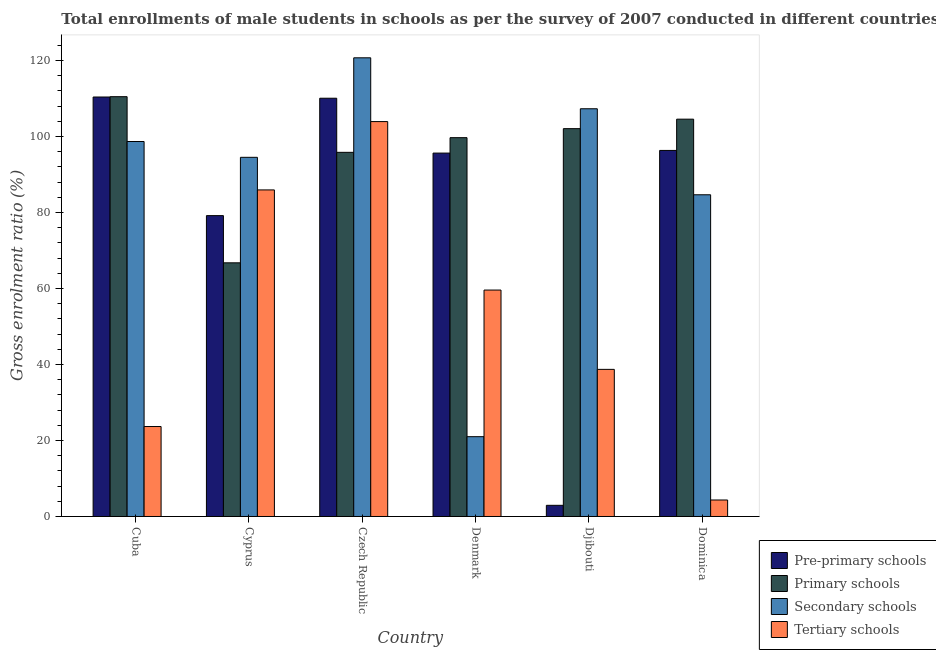How many different coloured bars are there?
Offer a very short reply. 4. Are the number of bars on each tick of the X-axis equal?
Give a very brief answer. Yes. How many bars are there on the 2nd tick from the left?
Your response must be concise. 4. How many bars are there on the 4th tick from the right?
Provide a succinct answer. 4. What is the label of the 3rd group of bars from the left?
Offer a terse response. Czech Republic. In how many cases, is the number of bars for a given country not equal to the number of legend labels?
Your response must be concise. 0. What is the gross enrolment ratio(male) in pre-primary schools in Denmark?
Offer a terse response. 95.65. Across all countries, what is the maximum gross enrolment ratio(male) in pre-primary schools?
Your answer should be very brief. 110.41. Across all countries, what is the minimum gross enrolment ratio(male) in secondary schools?
Provide a succinct answer. 21.01. In which country was the gross enrolment ratio(male) in pre-primary schools maximum?
Make the answer very short. Cuba. In which country was the gross enrolment ratio(male) in primary schools minimum?
Give a very brief answer. Cyprus. What is the total gross enrolment ratio(male) in tertiary schools in the graph?
Offer a very short reply. 316.23. What is the difference between the gross enrolment ratio(male) in secondary schools in Cyprus and that in Czech Republic?
Your response must be concise. -26.19. What is the difference between the gross enrolment ratio(male) in pre-primary schools in Denmark and the gross enrolment ratio(male) in secondary schools in Czech Republic?
Offer a terse response. -25.08. What is the average gross enrolment ratio(male) in pre-primary schools per country?
Your answer should be very brief. 82.44. What is the difference between the gross enrolment ratio(male) in tertiary schools and gross enrolment ratio(male) in primary schools in Dominica?
Keep it short and to the point. -100.24. In how many countries, is the gross enrolment ratio(male) in secondary schools greater than 20 %?
Your response must be concise. 6. What is the ratio of the gross enrolment ratio(male) in secondary schools in Cyprus to that in Denmark?
Make the answer very short. 4.5. What is the difference between the highest and the second highest gross enrolment ratio(male) in secondary schools?
Your answer should be compact. 13.41. What is the difference between the highest and the lowest gross enrolment ratio(male) in primary schools?
Offer a terse response. 43.73. What does the 1st bar from the left in Denmark represents?
Ensure brevity in your answer.  Pre-primary schools. What does the 3rd bar from the right in Cyprus represents?
Provide a succinct answer. Primary schools. How many countries are there in the graph?
Provide a short and direct response. 6. What is the difference between two consecutive major ticks on the Y-axis?
Provide a succinct answer. 20. Are the values on the major ticks of Y-axis written in scientific E-notation?
Give a very brief answer. No. Does the graph contain grids?
Give a very brief answer. No. Where does the legend appear in the graph?
Your response must be concise. Bottom right. How many legend labels are there?
Offer a terse response. 4. How are the legend labels stacked?
Offer a very short reply. Vertical. What is the title of the graph?
Provide a short and direct response. Total enrollments of male students in schools as per the survey of 2007 conducted in different countries. What is the label or title of the Y-axis?
Offer a terse response. Gross enrolment ratio (%). What is the Gross enrolment ratio (%) in Pre-primary schools in Cuba?
Provide a succinct answer. 110.41. What is the Gross enrolment ratio (%) of Primary schools in Cuba?
Ensure brevity in your answer.  110.49. What is the Gross enrolment ratio (%) in Secondary schools in Cuba?
Ensure brevity in your answer.  98.69. What is the Gross enrolment ratio (%) in Tertiary schools in Cuba?
Ensure brevity in your answer.  23.68. What is the Gross enrolment ratio (%) of Pre-primary schools in Cyprus?
Make the answer very short. 79.19. What is the Gross enrolment ratio (%) in Primary schools in Cyprus?
Give a very brief answer. 66.77. What is the Gross enrolment ratio (%) in Secondary schools in Cyprus?
Provide a short and direct response. 94.53. What is the Gross enrolment ratio (%) of Tertiary schools in Cyprus?
Ensure brevity in your answer.  85.95. What is the Gross enrolment ratio (%) in Pre-primary schools in Czech Republic?
Your answer should be very brief. 110.09. What is the Gross enrolment ratio (%) in Primary schools in Czech Republic?
Offer a very short reply. 95.84. What is the Gross enrolment ratio (%) in Secondary schools in Czech Republic?
Provide a succinct answer. 120.72. What is the Gross enrolment ratio (%) of Tertiary schools in Czech Republic?
Provide a succinct answer. 103.94. What is the Gross enrolment ratio (%) in Pre-primary schools in Denmark?
Offer a very short reply. 95.65. What is the Gross enrolment ratio (%) of Primary schools in Denmark?
Offer a terse response. 99.71. What is the Gross enrolment ratio (%) of Secondary schools in Denmark?
Your answer should be very brief. 21.01. What is the Gross enrolment ratio (%) of Tertiary schools in Denmark?
Provide a succinct answer. 59.6. What is the Gross enrolment ratio (%) of Pre-primary schools in Djibouti?
Make the answer very short. 2.94. What is the Gross enrolment ratio (%) in Primary schools in Djibouti?
Ensure brevity in your answer.  102.08. What is the Gross enrolment ratio (%) in Secondary schools in Djibouti?
Your answer should be compact. 107.32. What is the Gross enrolment ratio (%) of Tertiary schools in Djibouti?
Make the answer very short. 38.72. What is the Gross enrolment ratio (%) of Pre-primary schools in Dominica?
Ensure brevity in your answer.  96.35. What is the Gross enrolment ratio (%) of Primary schools in Dominica?
Make the answer very short. 104.58. What is the Gross enrolment ratio (%) of Secondary schools in Dominica?
Provide a short and direct response. 84.67. What is the Gross enrolment ratio (%) of Tertiary schools in Dominica?
Keep it short and to the point. 4.34. Across all countries, what is the maximum Gross enrolment ratio (%) of Pre-primary schools?
Give a very brief answer. 110.41. Across all countries, what is the maximum Gross enrolment ratio (%) in Primary schools?
Provide a short and direct response. 110.49. Across all countries, what is the maximum Gross enrolment ratio (%) in Secondary schools?
Offer a very short reply. 120.72. Across all countries, what is the maximum Gross enrolment ratio (%) of Tertiary schools?
Provide a short and direct response. 103.94. Across all countries, what is the minimum Gross enrolment ratio (%) of Pre-primary schools?
Offer a terse response. 2.94. Across all countries, what is the minimum Gross enrolment ratio (%) of Primary schools?
Your answer should be very brief. 66.77. Across all countries, what is the minimum Gross enrolment ratio (%) in Secondary schools?
Give a very brief answer. 21.01. Across all countries, what is the minimum Gross enrolment ratio (%) in Tertiary schools?
Make the answer very short. 4.34. What is the total Gross enrolment ratio (%) in Pre-primary schools in the graph?
Provide a short and direct response. 494.61. What is the total Gross enrolment ratio (%) in Primary schools in the graph?
Your answer should be very brief. 579.47. What is the total Gross enrolment ratio (%) in Secondary schools in the graph?
Your response must be concise. 526.95. What is the total Gross enrolment ratio (%) of Tertiary schools in the graph?
Your response must be concise. 316.23. What is the difference between the Gross enrolment ratio (%) of Pre-primary schools in Cuba and that in Cyprus?
Your answer should be very brief. 31.22. What is the difference between the Gross enrolment ratio (%) of Primary schools in Cuba and that in Cyprus?
Your answer should be compact. 43.73. What is the difference between the Gross enrolment ratio (%) in Secondary schools in Cuba and that in Cyprus?
Your answer should be very brief. 4.16. What is the difference between the Gross enrolment ratio (%) in Tertiary schools in Cuba and that in Cyprus?
Provide a succinct answer. -62.27. What is the difference between the Gross enrolment ratio (%) in Pre-primary schools in Cuba and that in Czech Republic?
Keep it short and to the point. 0.32. What is the difference between the Gross enrolment ratio (%) in Primary schools in Cuba and that in Czech Republic?
Provide a short and direct response. 14.65. What is the difference between the Gross enrolment ratio (%) of Secondary schools in Cuba and that in Czech Republic?
Keep it short and to the point. -22.03. What is the difference between the Gross enrolment ratio (%) of Tertiary schools in Cuba and that in Czech Republic?
Ensure brevity in your answer.  -80.26. What is the difference between the Gross enrolment ratio (%) of Pre-primary schools in Cuba and that in Denmark?
Offer a terse response. 14.76. What is the difference between the Gross enrolment ratio (%) in Primary schools in Cuba and that in Denmark?
Provide a short and direct response. 10.78. What is the difference between the Gross enrolment ratio (%) of Secondary schools in Cuba and that in Denmark?
Offer a terse response. 77.69. What is the difference between the Gross enrolment ratio (%) in Tertiary schools in Cuba and that in Denmark?
Provide a succinct answer. -35.92. What is the difference between the Gross enrolment ratio (%) of Pre-primary schools in Cuba and that in Djibouti?
Ensure brevity in your answer.  107.47. What is the difference between the Gross enrolment ratio (%) in Primary schools in Cuba and that in Djibouti?
Make the answer very short. 8.41. What is the difference between the Gross enrolment ratio (%) in Secondary schools in Cuba and that in Djibouti?
Offer a very short reply. -8.62. What is the difference between the Gross enrolment ratio (%) of Tertiary schools in Cuba and that in Djibouti?
Ensure brevity in your answer.  -15.04. What is the difference between the Gross enrolment ratio (%) in Pre-primary schools in Cuba and that in Dominica?
Provide a short and direct response. 14.06. What is the difference between the Gross enrolment ratio (%) in Primary schools in Cuba and that in Dominica?
Offer a very short reply. 5.92. What is the difference between the Gross enrolment ratio (%) in Secondary schools in Cuba and that in Dominica?
Provide a short and direct response. 14.02. What is the difference between the Gross enrolment ratio (%) in Tertiary schools in Cuba and that in Dominica?
Keep it short and to the point. 19.34. What is the difference between the Gross enrolment ratio (%) in Pre-primary schools in Cyprus and that in Czech Republic?
Offer a terse response. -30.9. What is the difference between the Gross enrolment ratio (%) of Primary schools in Cyprus and that in Czech Republic?
Provide a short and direct response. -29.08. What is the difference between the Gross enrolment ratio (%) of Secondary schools in Cyprus and that in Czech Republic?
Ensure brevity in your answer.  -26.19. What is the difference between the Gross enrolment ratio (%) of Tertiary schools in Cyprus and that in Czech Republic?
Offer a terse response. -17.99. What is the difference between the Gross enrolment ratio (%) in Pre-primary schools in Cyprus and that in Denmark?
Give a very brief answer. -16.46. What is the difference between the Gross enrolment ratio (%) of Primary schools in Cyprus and that in Denmark?
Your answer should be compact. -32.94. What is the difference between the Gross enrolment ratio (%) of Secondary schools in Cyprus and that in Denmark?
Offer a terse response. 73.53. What is the difference between the Gross enrolment ratio (%) of Tertiary schools in Cyprus and that in Denmark?
Ensure brevity in your answer.  26.35. What is the difference between the Gross enrolment ratio (%) of Pre-primary schools in Cyprus and that in Djibouti?
Ensure brevity in your answer.  76.25. What is the difference between the Gross enrolment ratio (%) of Primary schools in Cyprus and that in Djibouti?
Give a very brief answer. -35.31. What is the difference between the Gross enrolment ratio (%) in Secondary schools in Cyprus and that in Djibouti?
Make the answer very short. -12.79. What is the difference between the Gross enrolment ratio (%) of Tertiary schools in Cyprus and that in Djibouti?
Provide a succinct answer. 47.23. What is the difference between the Gross enrolment ratio (%) of Pre-primary schools in Cyprus and that in Dominica?
Give a very brief answer. -17.16. What is the difference between the Gross enrolment ratio (%) of Primary schools in Cyprus and that in Dominica?
Give a very brief answer. -37.81. What is the difference between the Gross enrolment ratio (%) of Secondary schools in Cyprus and that in Dominica?
Your answer should be compact. 9.86. What is the difference between the Gross enrolment ratio (%) of Tertiary schools in Cyprus and that in Dominica?
Your answer should be compact. 81.61. What is the difference between the Gross enrolment ratio (%) of Pre-primary schools in Czech Republic and that in Denmark?
Your response must be concise. 14.44. What is the difference between the Gross enrolment ratio (%) in Primary schools in Czech Republic and that in Denmark?
Your response must be concise. -3.86. What is the difference between the Gross enrolment ratio (%) in Secondary schools in Czech Republic and that in Denmark?
Ensure brevity in your answer.  99.72. What is the difference between the Gross enrolment ratio (%) of Tertiary schools in Czech Republic and that in Denmark?
Your answer should be compact. 44.34. What is the difference between the Gross enrolment ratio (%) in Pre-primary schools in Czech Republic and that in Djibouti?
Provide a short and direct response. 107.15. What is the difference between the Gross enrolment ratio (%) in Primary schools in Czech Republic and that in Djibouti?
Your response must be concise. -6.23. What is the difference between the Gross enrolment ratio (%) of Secondary schools in Czech Republic and that in Djibouti?
Provide a short and direct response. 13.41. What is the difference between the Gross enrolment ratio (%) in Tertiary schools in Czech Republic and that in Djibouti?
Your response must be concise. 65.22. What is the difference between the Gross enrolment ratio (%) of Pre-primary schools in Czech Republic and that in Dominica?
Provide a short and direct response. 13.74. What is the difference between the Gross enrolment ratio (%) of Primary schools in Czech Republic and that in Dominica?
Your answer should be very brief. -8.73. What is the difference between the Gross enrolment ratio (%) of Secondary schools in Czech Republic and that in Dominica?
Offer a very short reply. 36.05. What is the difference between the Gross enrolment ratio (%) of Tertiary schools in Czech Republic and that in Dominica?
Provide a succinct answer. 99.6. What is the difference between the Gross enrolment ratio (%) in Pre-primary schools in Denmark and that in Djibouti?
Provide a succinct answer. 92.71. What is the difference between the Gross enrolment ratio (%) in Primary schools in Denmark and that in Djibouti?
Ensure brevity in your answer.  -2.37. What is the difference between the Gross enrolment ratio (%) in Secondary schools in Denmark and that in Djibouti?
Provide a succinct answer. -86.31. What is the difference between the Gross enrolment ratio (%) in Tertiary schools in Denmark and that in Djibouti?
Offer a very short reply. 20.88. What is the difference between the Gross enrolment ratio (%) in Pre-primary schools in Denmark and that in Dominica?
Make the answer very short. -0.7. What is the difference between the Gross enrolment ratio (%) of Primary schools in Denmark and that in Dominica?
Your answer should be very brief. -4.87. What is the difference between the Gross enrolment ratio (%) in Secondary schools in Denmark and that in Dominica?
Give a very brief answer. -63.67. What is the difference between the Gross enrolment ratio (%) in Tertiary schools in Denmark and that in Dominica?
Provide a short and direct response. 55.26. What is the difference between the Gross enrolment ratio (%) of Pre-primary schools in Djibouti and that in Dominica?
Offer a terse response. -93.41. What is the difference between the Gross enrolment ratio (%) in Primary schools in Djibouti and that in Dominica?
Offer a very short reply. -2.5. What is the difference between the Gross enrolment ratio (%) in Secondary schools in Djibouti and that in Dominica?
Make the answer very short. 22.64. What is the difference between the Gross enrolment ratio (%) of Tertiary schools in Djibouti and that in Dominica?
Give a very brief answer. 34.38. What is the difference between the Gross enrolment ratio (%) in Pre-primary schools in Cuba and the Gross enrolment ratio (%) in Primary schools in Cyprus?
Provide a short and direct response. 43.64. What is the difference between the Gross enrolment ratio (%) of Pre-primary schools in Cuba and the Gross enrolment ratio (%) of Secondary schools in Cyprus?
Offer a very short reply. 15.87. What is the difference between the Gross enrolment ratio (%) of Pre-primary schools in Cuba and the Gross enrolment ratio (%) of Tertiary schools in Cyprus?
Your answer should be very brief. 24.45. What is the difference between the Gross enrolment ratio (%) of Primary schools in Cuba and the Gross enrolment ratio (%) of Secondary schools in Cyprus?
Provide a succinct answer. 15.96. What is the difference between the Gross enrolment ratio (%) in Primary schools in Cuba and the Gross enrolment ratio (%) in Tertiary schools in Cyprus?
Provide a short and direct response. 24.54. What is the difference between the Gross enrolment ratio (%) of Secondary schools in Cuba and the Gross enrolment ratio (%) of Tertiary schools in Cyprus?
Offer a very short reply. 12.74. What is the difference between the Gross enrolment ratio (%) in Pre-primary schools in Cuba and the Gross enrolment ratio (%) in Primary schools in Czech Republic?
Your answer should be compact. 14.56. What is the difference between the Gross enrolment ratio (%) of Pre-primary schools in Cuba and the Gross enrolment ratio (%) of Secondary schools in Czech Republic?
Your answer should be compact. -10.32. What is the difference between the Gross enrolment ratio (%) of Pre-primary schools in Cuba and the Gross enrolment ratio (%) of Tertiary schools in Czech Republic?
Offer a very short reply. 6.47. What is the difference between the Gross enrolment ratio (%) of Primary schools in Cuba and the Gross enrolment ratio (%) of Secondary schools in Czech Republic?
Provide a succinct answer. -10.23. What is the difference between the Gross enrolment ratio (%) of Primary schools in Cuba and the Gross enrolment ratio (%) of Tertiary schools in Czech Republic?
Provide a short and direct response. 6.55. What is the difference between the Gross enrolment ratio (%) in Secondary schools in Cuba and the Gross enrolment ratio (%) in Tertiary schools in Czech Republic?
Your answer should be very brief. -5.25. What is the difference between the Gross enrolment ratio (%) of Pre-primary schools in Cuba and the Gross enrolment ratio (%) of Primary schools in Denmark?
Your response must be concise. 10.7. What is the difference between the Gross enrolment ratio (%) in Pre-primary schools in Cuba and the Gross enrolment ratio (%) in Secondary schools in Denmark?
Make the answer very short. 89.4. What is the difference between the Gross enrolment ratio (%) in Pre-primary schools in Cuba and the Gross enrolment ratio (%) in Tertiary schools in Denmark?
Offer a terse response. 50.81. What is the difference between the Gross enrolment ratio (%) in Primary schools in Cuba and the Gross enrolment ratio (%) in Secondary schools in Denmark?
Make the answer very short. 89.49. What is the difference between the Gross enrolment ratio (%) of Primary schools in Cuba and the Gross enrolment ratio (%) of Tertiary schools in Denmark?
Give a very brief answer. 50.89. What is the difference between the Gross enrolment ratio (%) in Secondary schools in Cuba and the Gross enrolment ratio (%) in Tertiary schools in Denmark?
Your answer should be compact. 39.1. What is the difference between the Gross enrolment ratio (%) of Pre-primary schools in Cuba and the Gross enrolment ratio (%) of Primary schools in Djibouti?
Offer a very short reply. 8.33. What is the difference between the Gross enrolment ratio (%) in Pre-primary schools in Cuba and the Gross enrolment ratio (%) in Secondary schools in Djibouti?
Offer a terse response. 3.09. What is the difference between the Gross enrolment ratio (%) of Pre-primary schools in Cuba and the Gross enrolment ratio (%) of Tertiary schools in Djibouti?
Offer a terse response. 71.69. What is the difference between the Gross enrolment ratio (%) of Primary schools in Cuba and the Gross enrolment ratio (%) of Secondary schools in Djibouti?
Your answer should be very brief. 3.18. What is the difference between the Gross enrolment ratio (%) in Primary schools in Cuba and the Gross enrolment ratio (%) in Tertiary schools in Djibouti?
Give a very brief answer. 71.77. What is the difference between the Gross enrolment ratio (%) of Secondary schools in Cuba and the Gross enrolment ratio (%) of Tertiary schools in Djibouti?
Offer a terse response. 59.97. What is the difference between the Gross enrolment ratio (%) in Pre-primary schools in Cuba and the Gross enrolment ratio (%) in Primary schools in Dominica?
Your response must be concise. 5.83. What is the difference between the Gross enrolment ratio (%) of Pre-primary schools in Cuba and the Gross enrolment ratio (%) of Secondary schools in Dominica?
Offer a terse response. 25.73. What is the difference between the Gross enrolment ratio (%) in Pre-primary schools in Cuba and the Gross enrolment ratio (%) in Tertiary schools in Dominica?
Your response must be concise. 106.07. What is the difference between the Gross enrolment ratio (%) of Primary schools in Cuba and the Gross enrolment ratio (%) of Secondary schools in Dominica?
Provide a succinct answer. 25.82. What is the difference between the Gross enrolment ratio (%) of Primary schools in Cuba and the Gross enrolment ratio (%) of Tertiary schools in Dominica?
Your answer should be compact. 106.15. What is the difference between the Gross enrolment ratio (%) of Secondary schools in Cuba and the Gross enrolment ratio (%) of Tertiary schools in Dominica?
Your answer should be compact. 94.35. What is the difference between the Gross enrolment ratio (%) in Pre-primary schools in Cyprus and the Gross enrolment ratio (%) in Primary schools in Czech Republic?
Your answer should be compact. -16.66. What is the difference between the Gross enrolment ratio (%) in Pre-primary schools in Cyprus and the Gross enrolment ratio (%) in Secondary schools in Czech Republic?
Offer a very short reply. -41.54. What is the difference between the Gross enrolment ratio (%) of Pre-primary schools in Cyprus and the Gross enrolment ratio (%) of Tertiary schools in Czech Republic?
Ensure brevity in your answer.  -24.75. What is the difference between the Gross enrolment ratio (%) in Primary schools in Cyprus and the Gross enrolment ratio (%) in Secondary schools in Czech Republic?
Your answer should be very brief. -53.96. What is the difference between the Gross enrolment ratio (%) in Primary schools in Cyprus and the Gross enrolment ratio (%) in Tertiary schools in Czech Republic?
Offer a very short reply. -37.17. What is the difference between the Gross enrolment ratio (%) of Secondary schools in Cyprus and the Gross enrolment ratio (%) of Tertiary schools in Czech Republic?
Offer a very short reply. -9.41. What is the difference between the Gross enrolment ratio (%) in Pre-primary schools in Cyprus and the Gross enrolment ratio (%) in Primary schools in Denmark?
Give a very brief answer. -20.52. What is the difference between the Gross enrolment ratio (%) of Pre-primary schools in Cyprus and the Gross enrolment ratio (%) of Secondary schools in Denmark?
Your answer should be compact. 58.18. What is the difference between the Gross enrolment ratio (%) of Pre-primary schools in Cyprus and the Gross enrolment ratio (%) of Tertiary schools in Denmark?
Your answer should be compact. 19.59. What is the difference between the Gross enrolment ratio (%) of Primary schools in Cyprus and the Gross enrolment ratio (%) of Secondary schools in Denmark?
Keep it short and to the point. 45.76. What is the difference between the Gross enrolment ratio (%) in Primary schools in Cyprus and the Gross enrolment ratio (%) in Tertiary schools in Denmark?
Keep it short and to the point. 7.17. What is the difference between the Gross enrolment ratio (%) in Secondary schools in Cyprus and the Gross enrolment ratio (%) in Tertiary schools in Denmark?
Your response must be concise. 34.93. What is the difference between the Gross enrolment ratio (%) in Pre-primary schools in Cyprus and the Gross enrolment ratio (%) in Primary schools in Djibouti?
Offer a terse response. -22.89. What is the difference between the Gross enrolment ratio (%) of Pre-primary schools in Cyprus and the Gross enrolment ratio (%) of Secondary schools in Djibouti?
Ensure brevity in your answer.  -28.13. What is the difference between the Gross enrolment ratio (%) in Pre-primary schools in Cyprus and the Gross enrolment ratio (%) in Tertiary schools in Djibouti?
Offer a very short reply. 40.47. What is the difference between the Gross enrolment ratio (%) of Primary schools in Cyprus and the Gross enrolment ratio (%) of Secondary schools in Djibouti?
Give a very brief answer. -40.55. What is the difference between the Gross enrolment ratio (%) in Primary schools in Cyprus and the Gross enrolment ratio (%) in Tertiary schools in Djibouti?
Your answer should be compact. 28.05. What is the difference between the Gross enrolment ratio (%) in Secondary schools in Cyprus and the Gross enrolment ratio (%) in Tertiary schools in Djibouti?
Keep it short and to the point. 55.81. What is the difference between the Gross enrolment ratio (%) of Pre-primary schools in Cyprus and the Gross enrolment ratio (%) of Primary schools in Dominica?
Provide a short and direct response. -25.39. What is the difference between the Gross enrolment ratio (%) in Pre-primary schools in Cyprus and the Gross enrolment ratio (%) in Secondary schools in Dominica?
Make the answer very short. -5.49. What is the difference between the Gross enrolment ratio (%) in Pre-primary schools in Cyprus and the Gross enrolment ratio (%) in Tertiary schools in Dominica?
Make the answer very short. 74.85. What is the difference between the Gross enrolment ratio (%) in Primary schools in Cyprus and the Gross enrolment ratio (%) in Secondary schools in Dominica?
Make the answer very short. -17.91. What is the difference between the Gross enrolment ratio (%) in Primary schools in Cyprus and the Gross enrolment ratio (%) in Tertiary schools in Dominica?
Provide a short and direct response. 62.43. What is the difference between the Gross enrolment ratio (%) of Secondary schools in Cyprus and the Gross enrolment ratio (%) of Tertiary schools in Dominica?
Keep it short and to the point. 90.19. What is the difference between the Gross enrolment ratio (%) in Pre-primary schools in Czech Republic and the Gross enrolment ratio (%) in Primary schools in Denmark?
Provide a short and direct response. 10.38. What is the difference between the Gross enrolment ratio (%) of Pre-primary schools in Czech Republic and the Gross enrolment ratio (%) of Secondary schools in Denmark?
Provide a succinct answer. 89.08. What is the difference between the Gross enrolment ratio (%) of Pre-primary schools in Czech Republic and the Gross enrolment ratio (%) of Tertiary schools in Denmark?
Provide a short and direct response. 50.49. What is the difference between the Gross enrolment ratio (%) in Primary schools in Czech Republic and the Gross enrolment ratio (%) in Secondary schools in Denmark?
Your answer should be very brief. 74.84. What is the difference between the Gross enrolment ratio (%) in Primary schools in Czech Republic and the Gross enrolment ratio (%) in Tertiary schools in Denmark?
Keep it short and to the point. 36.25. What is the difference between the Gross enrolment ratio (%) of Secondary schools in Czech Republic and the Gross enrolment ratio (%) of Tertiary schools in Denmark?
Make the answer very short. 61.13. What is the difference between the Gross enrolment ratio (%) in Pre-primary schools in Czech Republic and the Gross enrolment ratio (%) in Primary schools in Djibouti?
Give a very brief answer. 8.01. What is the difference between the Gross enrolment ratio (%) in Pre-primary schools in Czech Republic and the Gross enrolment ratio (%) in Secondary schools in Djibouti?
Provide a short and direct response. 2.77. What is the difference between the Gross enrolment ratio (%) of Pre-primary schools in Czech Republic and the Gross enrolment ratio (%) of Tertiary schools in Djibouti?
Give a very brief answer. 71.37. What is the difference between the Gross enrolment ratio (%) of Primary schools in Czech Republic and the Gross enrolment ratio (%) of Secondary schools in Djibouti?
Your answer should be compact. -11.47. What is the difference between the Gross enrolment ratio (%) in Primary schools in Czech Republic and the Gross enrolment ratio (%) in Tertiary schools in Djibouti?
Provide a short and direct response. 57.13. What is the difference between the Gross enrolment ratio (%) of Secondary schools in Czech Republic and the Gross enrolment ratio (%) of Tertiary schools in Djibouti?
Make the answer very short. 82. What is the difference between the Gross enrolment ratio (%) of Pre-primary schools in Czech Republic and the Gross enrolment ratio (%) of Primary schools in Dominica?
Provide a short and direct response. 5.51. What is the difference between the Gross enrolment ratio (%) of Pre-primary schools in Czech Republic and the Gross enrolment ratio (%) of Secondary schools in Dominica?
Your response must be concise. 25.41. What is the difference between the Gross enrolment ratio (%) in Pre-primary schools in Czech Republic and the Gross enrolment ratio (%) in Tertiary schools in Dominica?
Provide a succinct answer. 105.75. What is the difference between the Gross enrolment ratio (%) in Primary schools in Czech Republic and the Gross enrolment ratio (%) in Secondary schools in Dominica?
Ensure brevity in your answer.  11.17. What is the difference between the Gross enrolment ratio (%) in Primary schools in Czech Republic and the Gross enrolment ratio (%) in Tertiary schools in Dominica?
Make the answer very short. 91.51. What is the difference between the Gross enrolment ratio (%) of Secondary schools in Czech Republic and the Gross enrolment ratio (%) of Tertiary schools in Dominica?
Provide a short and direct response. 116.39. What is the difference between the Gross enrolment ratio (%) of Pre-primary schools in Denmark and the Gross enrolment ratio (%) of Primary schools in Djibouti?
Make the answer very short. -6.43. What is the difference between the Gross enrolment ratio (%) in Pre-primary schools in Denmark and the Gross enrolment ratio (%) in Secondary schools in Djibouti?
Your answer should be very brief. -11.67. What is the difference between the Gross enrolment ratio (%) in Pre-primary schools in Denmark and the Gross enrolment ratio (%) in Tertiary schools in Djibouti?
Your answer should be compact. 56.93. What is the difference between the Gross enrolment ratio (%) in Primary schools in Denmark and the Gross enrolment ratio (%) in Secondary schools in Djibouti?
Give a very brief answer. -7.61. What is the difference between the Gross enrolment ratio (%) in Primary schools in Denmark and the Gross enrolment ratio (%) in Tertiary schools in Djibouti?
Keep it short and to the point. 60.99. What is the difference between the Gross enrolment ratio (%) in Secondary schools in Denmark and the Gross enrolment ratio (%) in Tertiary schools in Djibouti?
Your response must be concise. -17.71. What is the difference between the Gross enrolment ratio (%) in Pre-primary schools in Denmark and the Gross enrolment ratio (%) in Primary schools in Dominica?
Provide a short and direct response. -8.93. What is the difference between the Gross enrolment ratio (%) of Pre-primary schools in Denmark and the Gross enrolment ratio (%) of Secondary schools in Dominica?
Ensure brevity in your answer.  10.97. What is the difference between the Gross enrolment ratio (%) in Pre-primary schools in Denmark and the Gross enrolment ratio (%) in Tertiary schools in Dominica?
Your response must be concise. 91.31. What is the difference between the Gross enrolment ratio (%) of Primary schools in Denmark and the Gross enrolment ratio (%) of Secondary schools in Dominica?
Make the answer very short. 15.03. What is the difference between the Gross enrolment ratio (%) of Primary schools in Denmark and the Gross enrolment ratio (%) of Tertiary schools in Dominica?
Your response must be concise. 95.37. What is the difference between the Gross enrolment ratio (%) of Secondary schools in Denmark and the Gross enrolment ratio (%) of Tertiary schools in Dominica?
Provide a short and direct response. 16.67. What is the difference between the Gross enrolment ratio (%) in Pre-primary schools in Djibouti and the Gross enrolment ratio (%) in Primary schools in Dominica?
Ensure brevity in your answer.  -101.64. What is the difference between the Gross enrolment ratio (%) of Pre-primary schools in Djibouti and the Gross enrolment ratio (%) of Secondary schools in Dominica?
Your answer should be very brief. -81.74. What is the difference between the Gross enrolment ratio (%) in Pre-primary schools in Djibouti and the Gross enrolment ratio (%) in Tertiary schools in Dominica?
Make the answer very short. -1.4. What is the difference between the Gross enrolment ratio (%) of Primary schools in Djibouti and the Gross enrolment ratio (%) of Secondary schools in Dominica?
Your response must be concise. 17.4. What is the difference between the Gross enrolment ratio (%) in Primary schools in Djibouti and the Gross enrolment ratio (%) in Tertiary schools in Dominica?
Your answer should be compact. 97.74. What is the difference between the Gross enrolment ratio (%) in Secondary schools in Djibouti and the Gross enrolment ratio (%) in Tertiary schools in Dominica?
Offer a very short reply. 102.98. What is the average Gross enrolment ratio (%) in Pre-primary schools per country?
Keep it short and to the point. 82.44. What is the average Gross enrolment ratio (%) in Primary schools per country?
Keep it short and to the point. 96.58. What is the average Gross enrolment ratio (%) in Secondary schools per country?
Your answer should be compact. 87.82. What is the average Gross enrolment ratio (%) in Tertiary schools per country?
Provide a succinct answer. 52.7. What is the difference between the Gross enrolment ratio (%) in Pre-primary schools and Gross enrolment ratio (%) in Primary schools in Cuba?
Keep it short and to the point. -0.09. What is the difference between the Gross enrolment ratio (%) of Pre-primary schools and Gross enrolment ratio (%) of Secondary schools in Cuba?
Your response must be concise. 11.71. What is the difference between the Gross enrolment ratio (%) in Pre-primary schools and Gross enrolment ratio (%) in Tertiary schools in Cuba?
Offer a very short reply. 86.73. What is the difference between the Gross enrolment ratio (%) in Primary schools and Gross enrolment ratio (%) in Secondary schools in Cuba?
Provide a succinct answer. 11.8. What is the difference between the Gross enrolment ratio (%) of Primary schools and Gross enrolment ratio (%) of Tertiary schools in Cuba?
Make the answer very short. 86.82. What is the difference between the Gross enrolment ratio (%) of Secondary schools and Gross enrolment ratio (%) of Tertiary schools in Cuba?
Offer a very short reply. 75.02. What is the difference between the Gross enrolment ratio (%) of Pre-primary schools and Gross enrolment ratio (%) of Primary schools in Cyprus?
Provide a short and direct response. 12.42. What is the difference between the Gross enrolment ratio (%) of Pre-primary schools and Gross enrolment ratio (%) of Secondary schools in Cyprus?
Your answer should be compact. -15.34. What is the difference between the Gross enrolment ratio (%) in Pre-primary schools and Gross enrolment ratio (%) in Tertiary schools in Cyprus?
Provide a short and direct response. -6.77. What is the difference between the Gross enrolment ratio (%) of Primary schools and Gross enrolment ratio (%) of Secondary schools in Cyprus?
Ensure brevity in your answer.  -27.76. What is the difference between the Gross enrolment ratio (%) in Primary schools and Gross enrolment ratio (%) in Tertiary schools in Cyprus?
Provide a short and direct response. -19.19. What is the difference between the Gross enrolment ratio (%) of Secondary schools and Gross enrolment ratio (%) of Tertiary schools in Cyprus?
Offer a terse response. 8.58. What is the difference between the Gross enrolment ratio (%) of Pre-primary schools and Gross enrolment ratio (%) of Primary schools in Czech Republic?
Provide a succinct answer. 14.24. What is the difference between the Gross enrolment ratio (%) of Pre-primary schools and Gross enrolment ratio (%) of Secondary schools in Czech Republic?
Provide a short and direct response. -10.64. What is the difference between the Gross enrolment ratio (%) of Pre-primary schools and Gross enrolment ratio (%) of Tertiary schools in Czech Republic?
Offer a terse response. 6.15. What is the difference between the Gross enrolment ratio (%) of Primary schools and Gross enrolment ratio (%) of Secondary schools in Czech Republic?
Your answer should be very brief. -24.88. What is the difference between the Gross enrolment ratio (%) of Primary schools and Gross enrolment ratio (%) of Tertiary schools in Czech Republic?
Give a very brief answer. -8.1. What is the difference between the Gross enrolment ratio (%) of Secondary schools and Gross enrolment ratio (%) of Tertiary schools in Czech Republic?
Your response must be concise. 16.78. What is the difference between the Gross enrolment ratio (%) in Pre-primary schools and Gross enrolment ratio (%) in Primary schools in Denmark?
Offer a terse response. -4.06. What is the difference between the Gross enrolment ratio (%) in Pre-primary schools and Gross enrolment ratio (%) in Secondary schools in Denmark?
Offer a terse response. 74.64. What is the difference between the Gross enrolment ratio (%) of Pre-primary schools and Gross enrolment ratio (%) of Tertiary schools in Denmark?
Ensure brevity in your answer.  36.05. What is the difference between the Gross enrolment ratio (%) of Primary schools and Gross enrolment ratio (%) of Secondary schools in Denmark?
Offer a terse response. 78.7. What is the difference between the Gross enrolment ratio (%) in Primary schools and Gross enrolment ratio (%) in Tertiary schools in Denmark?
Make the answer very short. 40.11. What is the difference between the Gross enrolment ratio (%) in Secondary schools and Gross enrolment ratio (%) in Tertiary schools in Denmark?
Offer a very short reply. -38.59. What is the difference between the Gross enrolment ratio (%) in Pre-primary schools and Gross enrolment ratio (%) in Primary schools in Djibouti?
Provide a succinct answer. -99.14. What is the difference between the Gross enrolment ratio (%) in Pre-primary schools and Gross enrolment ratio (%) in Secondary schools in Djibouti?
Ensure brevity in your answer.  -104.38. What is the difference between the Gross enrolment ratio (%) in Pre-primary schools and Gross enrolment ratio (%) in Tertiary schools in Djibouti?
Keep it short and to the point. -35.78. What is the difference between the Gross enrolment ratio (%) in Primary schools and Gross enrolment ratio (%) in Secondary schools in Djibouti?
Your answer should be compact. -5.24. What is the difference between the Gross enrolment ratio (%) of Primary schools and Gross enrolment ratio (%) of Tertiary schools in Djibouti?
Give a very brief answer. 63.36. What is the difference between the Gross enrolment ratio (%) of Secondary schools and Gross enrolment ratio (%) of Tertiary schools in Djibouti?
Offer a very short reply. 68.6. What is the difference between the Gross enrolment ratio (%) in Pre-primary schools and Gross enrolment ratio (%) in Primary schools in Dominica?
Provide a succinct answer. -8.23. What is the difference between the Gross enrolment ratio (%) in Pre-primary schools and Gross enrolment ratio (%) in Secondary schools in Dominica?
Provide a short and direct response. 11.67. What is the difference between the Gross enrolment ratio (%) of Pre-primary schools and Gross enrolment ratio (%) of Tertiary schools in Dominica?
Keep it short and to the point. 92.01. What is the difference between the Gross enrolment ratio (%) of Primary schools and Gross enrolment ratio (%) of Secondary schools in Dominica?
Your response must be concise. 19.9. What is the difference between the Gross enrolment ratio (%) of Primary schools and Gross enrolment ratio (%) of Tertiary schools in Dominica?
Give a very brief answer. 100.24. What is the difference between the Gross enrolment ratio (%) in Secondary schools and Gross enrolment ratio (%) in Tertiary schools in Dominica?
Offer a terse response. 80.34. What is the ratio of the Gross enrolment ratio (%) of Pre-primary schools in Cuba to that in Cyprus?
Your answer should be very brief. 1.39. What is the ratio of the Gross enrolment ratio (%) of Primary schools in Cuba to that in Cyprus?
Provide a short and direct response. 1.65. What is the ratio of the Gross enrolment ratio (%) of Secondary schools in Cuba to that in Cyprus?
Ensure brevity in your answer.  1.04. What is the ratio of the Gross enrolment ratio (%) of Tertiary schools in Cuba to that in Cyprus?
Keep it short and to the point. 0.28. What is the ratio of the Gross enrolment ratio (%) of Pre-primary schools in Cuba to that in Czech Republic?
Provide a succinct answer. 1. What is the ratio of the Gross enrolment ratio (%) in Primary schools in Cuba to that in Czech Republic?
Keep it short and to the point. 1.15. What is the ratio of the Gross enrolment ratio (%) of Secondary schools in Cuba to that in Czech Republic?
Provide a short and direct response. 0.82. What is the ratio of the Gross enrolment ratio (%) of Tertiary schools in Cuba to that in Czech Republic?
Keep it short and to the point. 0.23. What is the ratio of the Gross enrolment ratio (%) of Pre-primary schools in Cuba to that in Denmark?
Your answer should be compact. 1.15. What is the ratio of the Gross enrolment ratio (%) in Primary schools in Cuba to that in Denmark?
Your answer should be very brief. 1.11. What is the ratio of the Gross enrolment ratio (%) in Secondary schools in Cuba to that in Denmark?
Your answer should be compact. 4.7. What is the ratio of the Gross enrolment ratio (%) in Tertiary schools in Cuba to that in Denmark?
Offer a very short reply. 0.4. What is the ratio of the Gross enrolment ratio (%) in Pre-primary schools in Cuba to that in Djibouti?
Offer a very short reply. 37.58. What is the ratio of the Gross enrolment ratio (%) in Primary schools in Cuba to that in Djibouti?
Provide a succinct answer. 1.08. What is the ratio of the Gross enrolment ratio (%) in Secondary schools in Cuba to that in Djibouti?
Make the answer very short. 0.92. What is the ratio of the Gross enrolment ratio (%) in Tertiary schools in Cuba to that in Djibouti?
Your answer should be very brief. 0.61. What is the ratio of the Gross enrolment ratio (%) of Pre-primary schools in Cuba to that in Dominica?
Offer a very short reply. 1.15. What is the ratio of the Gross enrolment ratio (%) in Primary schools in Cuba to that in Dominica?
Provide a short and direct response. 1.06. What is the ratio of the Gross enrolment ratio (%) of Secondary schools in Cuba to that in Dominica?
Give a very brief answer. 1.17. What is the ratio of the Gross enrolment ratio (%) in Tertiary schools in Cuba to that in Dominica?
Keep it short and to the point. 5.46. What is the ratio of the Gross enrolment ratio (%) of Pre-primary schools in Cyprus to that in Czech Republic?
Your answer should be compact. 0.72. What is the ratio of the Gross enrolment ratio (%) in Primary schools in Cyprus to that in Czech Republic?
Offer a terse response. 0.7. What is the ratio of the Gross enrolment ratio (%) of Secondary schools in Cyprus to that in Czech Republic?
Offer a terse response. 0.78. What is the ratio of the Gross enrolment ratio (%) in Tertiary schools in Cyprus to that in Czech Republic?
Your answer should be very brief. 0.83. What is the ratio of the Gross enrolment ratio (%) of Pre-primary schools in Cyprus to that in Denmark?
Give a very brief answer. 0.83. What is the ratio of the Gross enrolment ratio (%) of Primary schools in Cyprus to that in Denmark?
Your response must be concise. 0.67. What is the ratio of the Gross enrolment ratio (%) of Secondary schools in Cyprus to that in Denmark?
Provide a short and direct response. 4.5. What is the ratio of the Gross enrolment ratio (%) of Tertiary schools in Cyprus to that in Denmark?
Make the answer very short. 1.44. What is the ratio of the Gross enrolment ratio (%) in Pre-primary schools in Cyprus to that in Djibouti?
Your response must be concise. 26.96. What is the ratio of the Gross enrolment ratio (%) of Primary schools in Cyprus to that in Djibouti?
Provide a succinct answer. 0.65. What is the ratio of the Gross enrolment ratio (%) in Secondary schools in Cyprus to that in Djibouti?
Give a very brief answer. 0.88. What is the ratio of the Gross enrolment ratio (%) of Tertiary schools in Cyprus to that in Djibouti?
Your answer should be very brief. 2.22. What is the ratio of the Gross enrolment ratio (%) of Pre-primary schools in Cyprus to that in Dominica?
Give a very brief answer. 0.82. What is the ratio of the Gross enrolment ratio (%) in Primary schools in Cyprus to that in Dominica?
Provide a succinct answer. 0.64. What is the ratio of the Gross enrolment ratio (%) of Secondary schools in Cyprus to that in Dominica?
Make the answer very short. 1.12. What is the ratio of the Gross enrolment ratio (%) of Tertiary schools in Cyprus to that in Dominica?
Make the answer very short. 19.81. What is the ratio of the Gross enrolment ratio (%) in Pre-primary schools in Czech Republic to that in Denmark?
Offer a terse response. 1.15. What is the ratio of the Gross enrolment ratio (%) in Primary schools in Czech Republic to that in Denmark?
Your answer should be very brief. 0.96. What is the ratio of the Gross enrolment ratio (%) of Secondary schools in Czech Republic to that in Denmark?
Ensure brevity in your answer.  5.75. What is the ratio of the Gross enrolment ratio (%) in Tertiary schools in Czech Republic to that in Denmark?
Provide a succinct answer. 1.74. What is the ratio of the Gross enrolment ratio (%) of Pre-primary schools in Czech Republic to that in Djibouti?
Give a very brief answer. 37.48. What is the ratio of the Gross enrolment ratio (%) in Primary schools in Czech Republic to that in Djibouti?
Offer a terse response. 0.94. What is the ratio of the Gross enrolment ratio (%) of Secondary schools in Czech Republic to that in Djibouti?
Provide a succinct answer. 1.12. What is the ratio of the Gross enrolment ratio (%) in Tertiary schools in Czech Republic to that in Djibouti?
Give a very brief answer. 2.68. What is the ratio of the Gross enrolment ratio (%) in Pre-primary schools in Czech Republic to that in Dominica?
Keep it short and to the point. 1.14. What is the ratio of the Gross enrolment ratio (%) of Primary schools in Czech Republic to that in Dominica?
Offer a terse response. 0.92. What is the ratio of the Gross enrolment ratio (%) of Secondary schools in Czech Republic to that in Dominica?
Offer a very short reply. 1.43. What is the ratio of the Gross enrolment ratio (%) in Tertiary schools in Czech Republic to that in Dominica?
Provide a succinct answer. 23.95. What is the ratio of the Gross enrolment ratio (%) of Pre-primary schools in Denmark to that in Djibouti?
Your answer should be compact. 32.56. What is the ratio of the Gross enrolment ratio (%) in Primary schools in Denmark to that in Djibouti?
Give a very brief answer. 0.98. What is the ratio of the Gross enrolment ratio (%) in Secondary schools in Denmark to that in Djibouti?
Provide a succinct answer. 0.2. What is the ratio of the Gross enrolment ratio (%) of Tertiary schools in Denmark to that in Djibouti?
Offer a very short reply. 1.54. What is the ratio of the Gross enrolment ratio (%) of Primary schools in Denmark to that in Dominica?
Provide a short and direct response. 0.95. What is the ratio of the Gross enrolment ratio (%) in Secondary schools in Denmark to that in Dominica?
Keep it short and to the point. 0.25. What is the ratio of the Gross enrolment ratio (%) of Tertiary schools in Denmark to that in Dominica?
Keep it short and to the point. 13.73. What is the ratio of the Gross enrolment ratio (%) of Pre-primary schools in Djibouti to that in Dominica?
Ensure brevity in your answer.  0.03. What is the ratio of the Gross enrolment ratio (%) in Primary schools in Djibouti to that in Dominica?
Your answer should be compact. 0.98. What is the ratio of the Gross enrolment ratio (%) of Secondary schools in Djibouti to that in Dominica?
Offer a very short reply. 1.27. What is the ratio of the Gross enrolment ratio (%) in Tertiary schools in Djibouti to that in Dominica?
Provide a short and direct response. 8.92. What is the difference between the highest and the second highest Gross enrolment ratio (%) in Pre-primary schools?
Offer a terse response. 0.32. What is the difference between the highest and the second highest Gross enrolment ratio (%) in Primary schools?
Make the answer very short. 5.92. What is the difference between the highest and the second highest Gross enrolment ratio (%) in Secondary schools?
Provide a succinct answer. 13.41. What is the difference between the highest and the second highest Gross enrolment ratio (%) of Tertiary schools?
Your response must be concise. 17.99. What is the difference between the highest and the lowest Gross enrolment ratio (%) of Pre-primary schools?
Provide a succinct answer. 107.47. What is the difference between the highest and the lowest Gross enrolment ratio (%) of Primary schools?
Provide a short and direct response. 43.73. What is the difference between the highest and the lowest Gross enrolment ratio (%) of Secondary schools?
Give a very brief answer. 99.72. What is the difference between the highest and the lowest Gross enrolment ratio (%) of Tertiary schools?
Give a very brief answer. 99.6. 